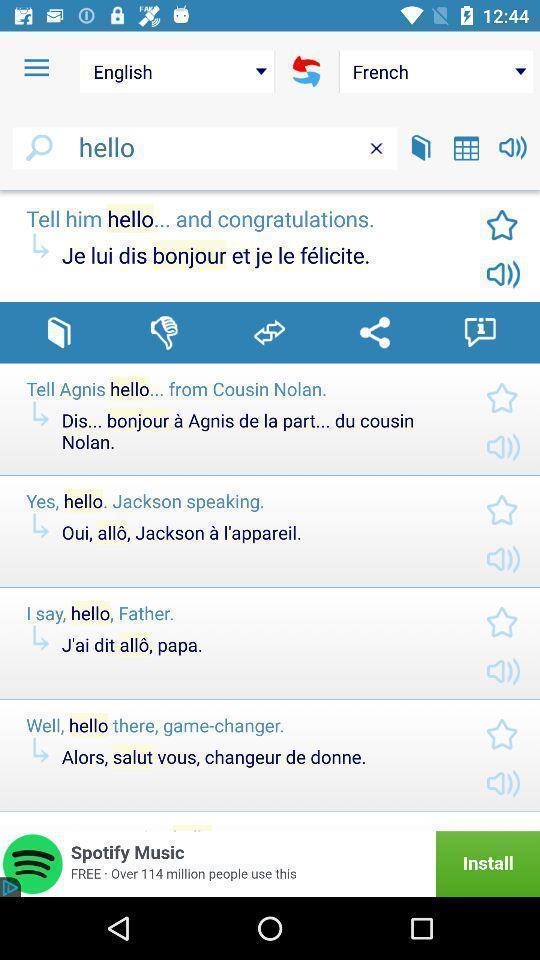Give me a narrative description of this picture. Search bar to search for word in language translator app. 